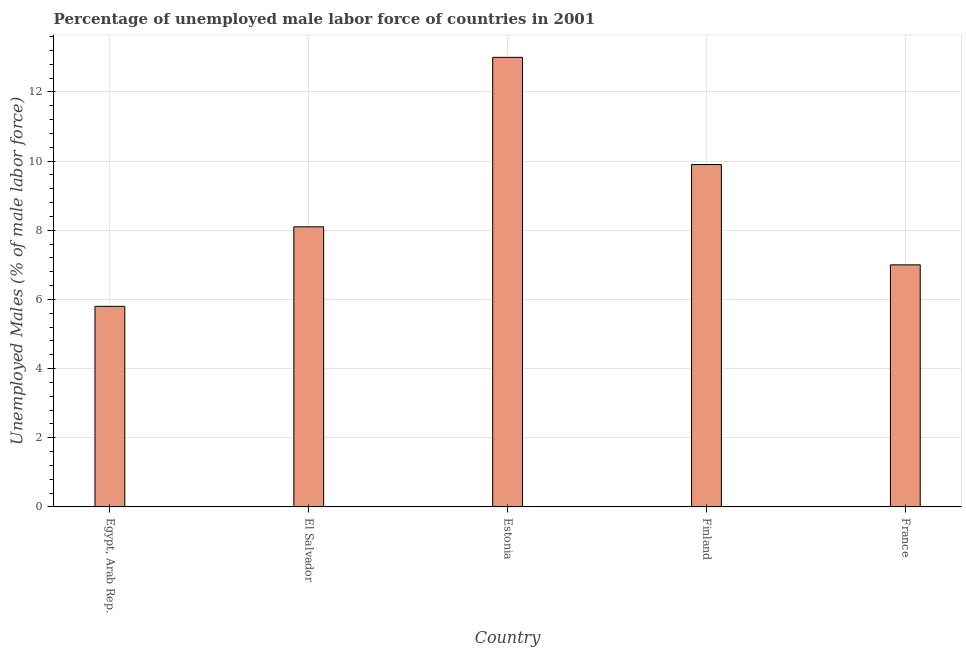Does the graph contain any zero values?
Provide a short and direct response. No. What is the title of the graph?
Offer a very short reply. Percentage of unemployed male labor force of countries in 2001. What is the label or title of the X-axis?
Provide a short and direct response. Country. What is the label or title of the Y-axis?
Your answer should be very brief. Unemployed Males (% of male labor force). What is the total unemployed male labour force in Egypt, Arab Rep.?
Provide a short and direct response. 5.8. Across all countries, what is the maximum total unemployed male labour force?
Keep it short and to the point. 13. Across all countries, what is the minimum total unemployed male labour force?
Provide a succinct answer. 5.8. In which country was the total unemployed male labour force maximum?
Give a very brief answer. Estonia. In which country was the total unemployed male labour force minimum?
Make the answer very short. Egypt, Arab Rep. What is the sum of the total unemployed male labour force?
Your answer should be very brief. 43.8. What is the difference between the total unemployed male labour force in Egypt, Arab Rep. and France?
Give a very brief answer. -1.2. What is the average total unemployed male labour force per country?
Provide a succinct answer. 8.76. What is the median total unemployed male labour force?
Your response must be concise. 8.1. In how many countries, is the total unemployed male labour force greater than 10 %?
Provide a short and direct response. 1. What is the ratio of the total unemployed male labour force in Egypt, Arab Rep. to that in Finland?
Ensure brevity in your answer.  0.59. Is the difference between the total unemployed male labour force in Egypt, Arab Rep. and El Salvador greater than the difference between any two countries?
Give a very brief answer. No. What is the difference between the highest and the lowest total unemployed male labour force?
Ensure brevity in your answer.  7.2. Are all the bars in the graph horizontal?
Offer a very short reply. No. How many countries are there in the graph?
Provide a short and direct response. 5. What is the difference between two consecutive major ticks on the Y-axis?
Ensure brevity in your answer.  2. What is the Unemployed Males (% of male labor force) of Egypt, Arab Rep.?
Provide a succinct answer. 5.8. What is the Unemployed Males (% of male labor force) of El Salvador?
Your answer should be very brief. 8.1. What is the Unemployed Males (% of male labor force) in Finland?
Keep it short and to the point. 9.9. What is the difference between the Unemployed Males (% of male labor force) in Egypt, Arab Rep. and Estonia?
Your answer should be very brief. -7.2. What is the difference between the Unemployed Males (% of male labor force) in Egypt, Arab Rep. and Finland?
Give a very brief answer. -4.1. What is the difference between the Unemployed Males (% of male labor force) in Egypt, Arab Rep. and France?
Ensure brevity in your answer.  -1.2. What is the difference between the Unemployed Males (% of male labor force) in El Salvador and Finland?
Ensure brevity in your answer.  -1.8. What is the difference between the Unemployed Males (% of male labor force) in El Salvador and France?
Provide a short and direct response. 1.1. What is the difference between the Unemployed Males (% of male labor force) in Estonia and France?
Offer a terse response. 6. What is the difference between the Unemployed Males (% of male labor force) in Finland and France?
Offer a terse response. 2.9. What is the ratio of the Unemployed Males (% of male labor force) in Egypt, Arab Rep. to that in El Salvador?
Give a very brief answer. 0.72. What is the ratio of the Unemployed Males (% of male labor force) in Egypt, Arab Rep. to that in Estonia?
Provide a succinct answer. 0.45. What is the ratio of the Unemployed Males (% of male labor force) in Egypt, Arab Rep. to that in Finland?
Keep it short and to the point. 0.59. What is the ratio of the Unemployed Males (% of male labor force) in Egypt, Arab Rep. to that in France?
Provide a succinct answer. 0.83. What is the ratio of the Unemployed Males (% of male labor force) in El Salvador to that in Estonia?
Give a very brief answer. 0.62. What is the ratio of the Unemployed Males (% of male labor force) in El Salvador to that in Finland?
Keep it short and to the point. 0.82. What is the ratio of the Unemployed Males (% of male labor force) in El Salvador to that in France?
Give a very brief answer. 1.16. What is the ratio of the Unemployed Males (% of male labor force) in Estonia to that in Finland?
Keep it short and to the point. 1.31. What is the ratio of the Unemployed Males (% of male labor force) in Estonia to that in France?
Give a very brief answer. 1.86. What is the ratio of the Unemployed Males (% of male labor force) in Finland to that in France?
Offer a very short reply. 1.41. 